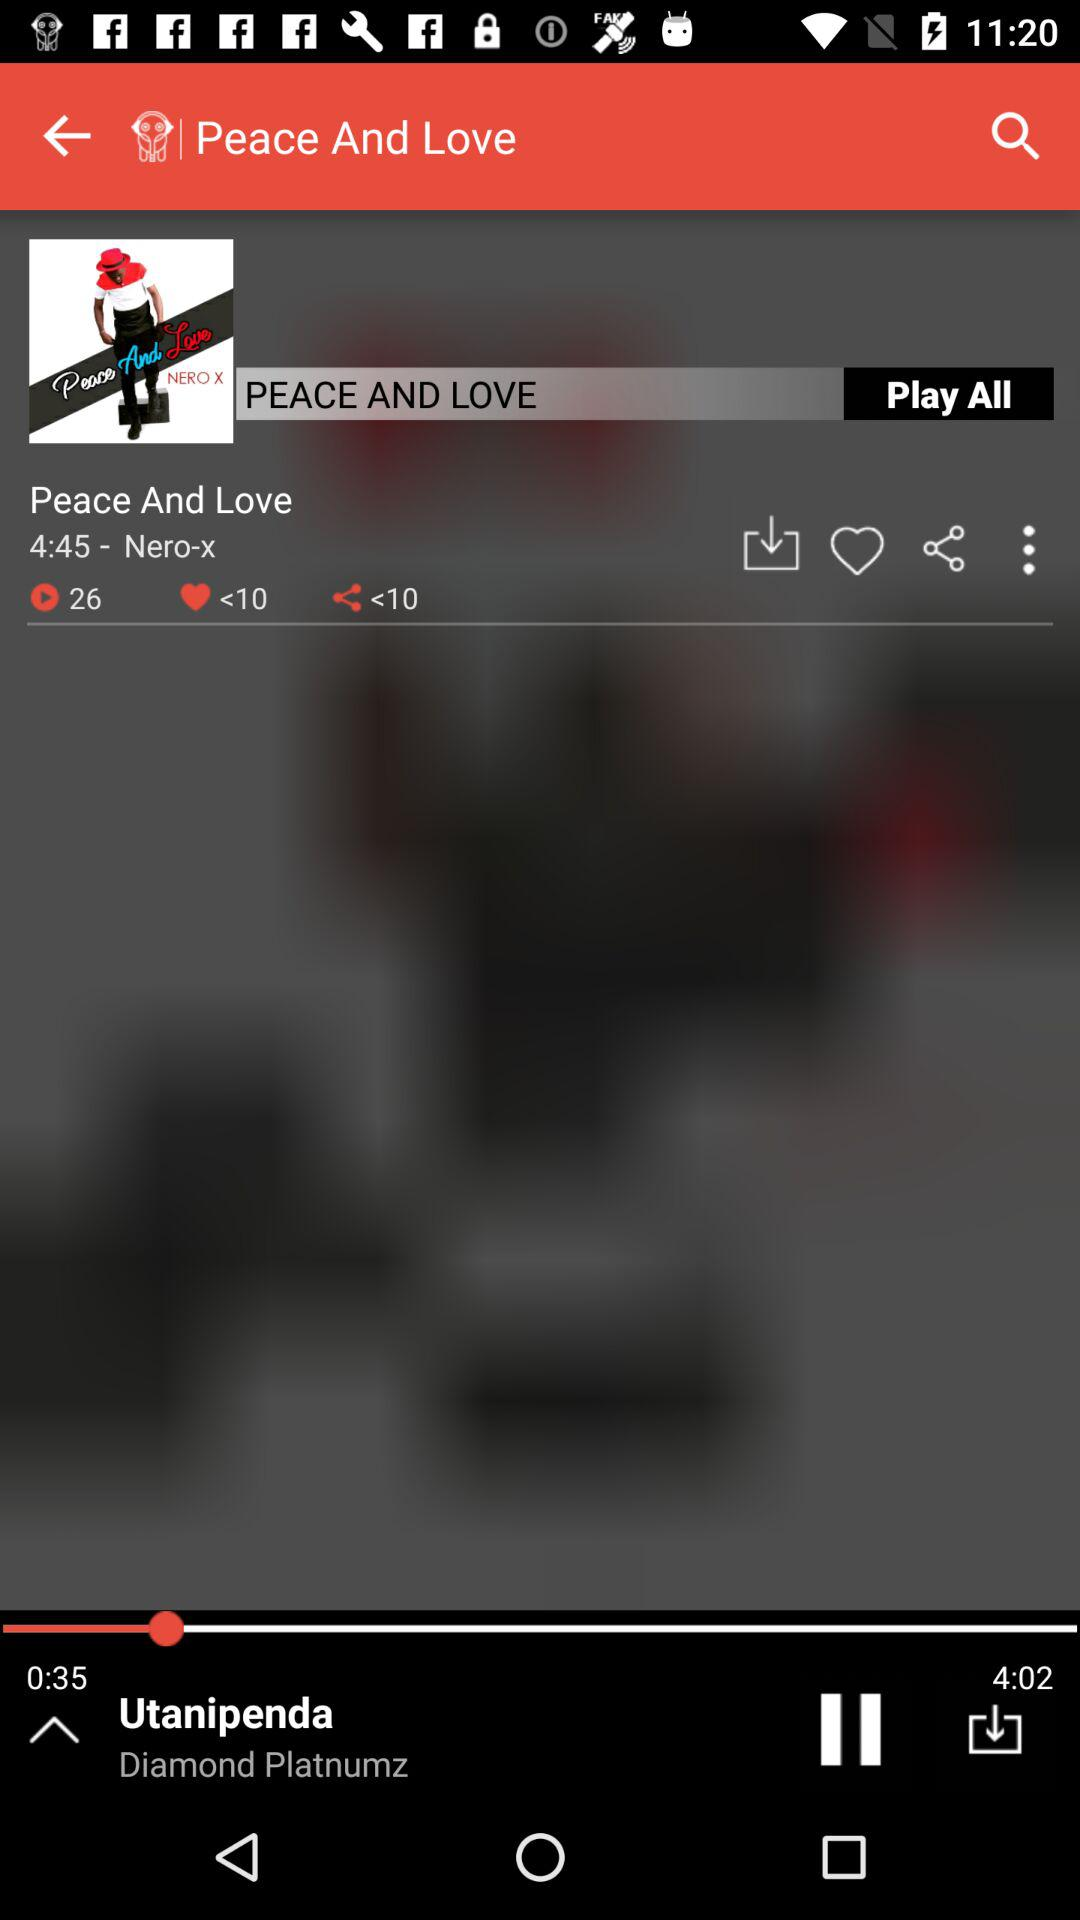What is the duration of the song currently playing? The duration of the song currently playing is 4 minutes and 2 seconds. 